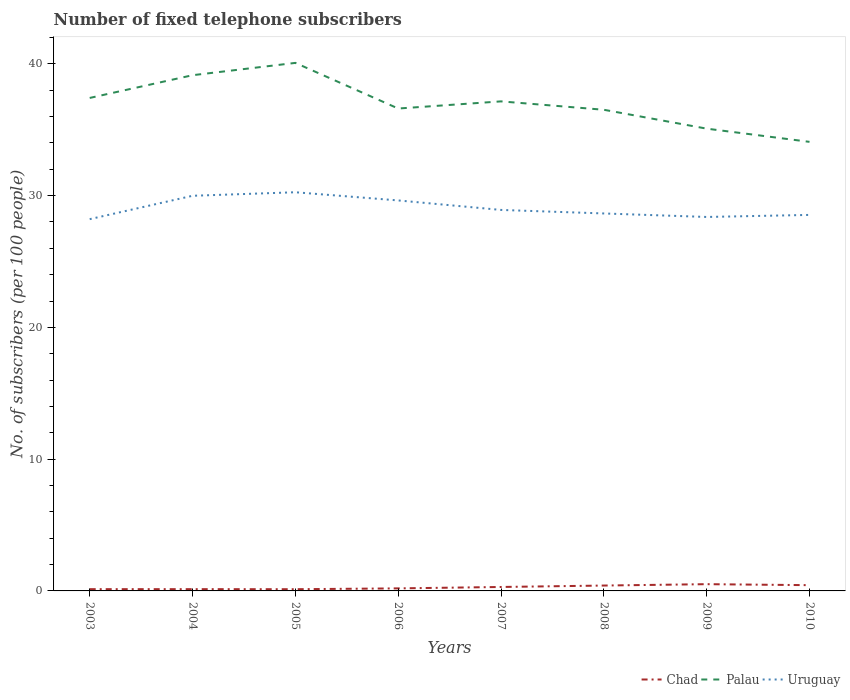Across all years, what is the maximum number of fixed telephone subscribers in Palau?
Make the answer very short. 34.08. In which year was the number of fixed telephone subscribers in Chad maximum?
Provide a short and direct response. 2005. What is the total number of fixed telephone subscribers in Uruguay in the graph?
Keep it short and to the point. 0.62. What is the difference between the highest and the second highest number of fixed telephone subscribers in Uruguay?
Offer a very short reply. 2.04. What is the difference between the highest and the lowest number of fixed telephone subscribers in Chad?
Offer a terse response. 4. Is the number of fixed telephone subscribers in Uruguay strictly greater than the number of fixed telephone subscribers in Chad over the years?
Give a very brief answer. No. How many years are there in the graph?
Provide a succinct answer. 8. What is the difference between two consecutive major ticks on the Y-axis?
Your answer should be very brief. 10. Where does the legend appear in the graph?
Ensure brevity in your answer.  Bottom right. How many legend labels are there?
Your response must be concise. 3. What is the title of the graph?
Offer a very short reply. Number of fixed telephone subscribers. Does "Europe(developing only)" appear as one of the legend labels in the graph?
Your response must be concise. No. What is the label or title of the Y-axis?
Your response must be concise. No. of subscribers (per 100 people). What is the No. of subscribers (per 100 people) in Chad in 2003?
Provide a succinct answer. 0.13. What is the No. of subscribers (per 100 people) in Palau in 2003?
Offer a terse response. 37.41. What is the No. of subscribers (per 100 people) of Uruguay in 2003?
Provide a succinct answer. 28.21. What is the No. of subscribers (per 100 people) of Chad in 2004?
Your answer should be compact. 0.13. What is the No. of subscribers (per 100 people) of Palau in 2004?
Keep it short and to the point. 39.14. What is the No. of subscribers (per 100 people) in Uruguay in 2004?
Offer a terse response. 29.99. What is the No. of subscribers (per 100 people) of Chad in 2005?
Your response must be concise. 0.13. What is the No. of subscribers (per 100 people) in Palau in 2005?
Offer a very short reply. 40.07. What is the No. of subscribers (per 100 people) of Uruguay in 2005?
Provide a short and direct response. 30.25. What is the No. of subscribers (per 100 people) in Chad in 2006?
Your answer should be very brief. 0.19. What is the No. of subscribers (per 100 people) of Palau in 2006?
Provide a succinct answer. 36.61. What is the No. of subscribers (per 100 people) of Uruguay in 2006?
Give a very brief answer. 29.63. What is the No. of subscribers (per 100 people) in Chad in 2007?
Provide a short and direct response. 0.3. What is the No. of subscribers (per 100 people) of Palau in 2007?
Provide a short and direct response. 37.15. What is the No. of subscribers (per 100 people) of Uruguay in 2007?
Your response must be concise. 28.91. What is the No. of subscribers (per 100 people) of Chad in 2008?
Provide a short and direct response. 0.41. What is the No. of subscribers (per 100 people) of Palau in 2008?
Provide a short and direct response. 36.51. What is the No. of subscribers (per 100 people) of Uruguay in 2008?
Your answer should be very brief. 28.64. What is the No. of subscribers (per 100 people) in Chad in 2009?
Give a very brief answer. 0.51. What is the No. of subscribers (per 100 people) in Palau in 2009?
Your answer should be compact. 35.08. What is the No. of subscribers (per 100 people) in Uruguay in 2009?
Your answer should be compact. 28.38. What is the No. of subscribers (per 100 people) of Chad in 2010?
Keep it short and to the point. 0.44. What is the No. of subscribers (per 100 people) in Palau in 2010?
Offer a terse response. 34.08. What is the No. of subscribers (per 100 people) of Uruguay in 2010?
Your response must be concise. 28.53. Across all years, what is the maximum No. of subscribers (per 100 people) of Chad?
Your answer should be very brief. 0.51. Across all years, what is the maximum No. of subscribers (per 100 people) in Palau?
Keep it short and to the point. 40.07. Across all years, what is the maximum No. of subscribers (per 100 people) of Uruguay?
Offer a very short reply. 30.25. Across all years, what is the minimum No. of subscribers (per 100 people) in Chad?
Your answer should be very brief. 0.13. Across all years, what is the minimum No. of subscribers (per 100 people) of Palau?
Provide a succinct answer. 34.08. Across all years, what is the minimum No. of subscribers (per 100 people) in Uruguay?
Your answer should be very brief. 28.21. What is the total No. of subscribers (per 100 people) of Chad in the graph?
Keep it short and to the point. 2.25. What is the total No. of subscribers (per 100 people) in Palau in the graph?
Your answer should be very brief. 296.05. What is the total No. of subscribers (per 100 people) in Uruguay in the graph?
Provide a succinct answer. 232.56. What is the difference between the No. of subscribers (per 100 people) in Chad in 2003 and that in 2004?
Your answer should be compact. -0. What is the difference between the No. of subscribers (per 100 people) of Palau in 2003 and that in 2004?
Provide a succinct answer. -1.73. What is the difference between the No. of subscribers (per 100 people) of Uruguay in 2003 and that in 2004?
Keep it short and to the point. -1.77. What is the difference between the No. of subscribers (per 100 people) in Chad in 2003 and that in 2005?
Provide a short and direct response. 0. What is the difference between the No. of subscribers (per 100 people) of Palau in 2003 and that in 2005?
Keep it short and to the point. -2.66. What is the difference between the No. of subscribers (per 100 people) in Uruguay in 2003 and that in 2005?
Give a very brief answer. -2.04. What is the difference between the No. of subscribers (per 100 people) in Chad in 2003 and that in 2006?
Provide a succinct answer. -0.06. What is the difference between the No. of subscribers (per 100 people) in Palau in 2003 and that in 2006?
Your response must be concise. 0.8. What is the difference between the No. of subscribers (per 100 people) of Uruguay in 2003 and that in 2006?
Ensure brevity in your answer.  -1.42. What is the difference between the No. of subscribers (per 100 people) of Chad in 2003 and that in 2007?
Ensure brevity in your answer.  -0.17. What is the difference between the No. of subscribers (per 100 people) of Palau in 2003 and that in 2007?
Give a very brief answer. 0.26. What is the difference between the No. of subscribers (per 100 people) in Chad in 2003 and that in 2008?
Ensure brevity in your answer.  -0.27. What is the difference between the No. of subscribers (per 100 people) of Palau in 2003 and that in 2008?
Ensure brevity in your answer.  0.9. What is the difference between the No. of subscribers (per 100 people) in Uruguay in 2003 and that in 2008?
Provide a succinct answer. -0.43. What is the difference between the No. of subscribers (per 100 people) of Chad in 2003 and that in 2009?
Offer a very short reply. -0.38. What is the difference between the No. of subscribers (per 100 people) of Palau in 2003 and that in 2009?
Provide a succinct answer. 2.33. What is the difference between the No. of subscribers (per 100 people) in Uruguay in 2003 and that in 2009?
Make the answer very short. -0.17. What is the difference between the No. of subscribers (per 100 people) of Chad in 2003 and that in 2010?
Your answer should be compact. -0.3. What is the difference between the No. of subscribers (per 100 people) in Palau in 2003 and that in 2010?
Your answer should be compact. 3.33. What is the difference between the No. of subscribers (per 100 people) in Uruguay in 2003 and that in 2010?
Your answer should be very brief. -0.32. What is the difference between the No. of subscribers (per 100 people) in Chad in 2004 and that in 2005?
Offer a terse response. 0. What is the difference between the No. of subscribers (per 100 people) in Palau in 2004 and that in 2005?
Make the answer very short. -0.93. What is the difference between the No. of subscribers (per 100 people) of Uruguay in 2004 and that in 2005?
Ensure brevity in your answer.  -0.27. What is the difference between the No. of subscribers (per 100 people) in Chad in 2004 and that in 2006?
Your response must be concise. -0.06. What is the difference between the No. of subscribers (per 100 people) of Palau in 2004 and that in 2006?
Keep it short and to the point. 2.53. What is the difference between the No. of subscribers (per 100 people) in Uruguay in 2004 and that in 2006?
Your answer should be compact. 0.35. What is the difference between the No. of subscribers (per 100 people) of Chad in 2004 and that in 2007?
Keep it short and to the point. -0.16. What is the difference between the No. of subscribers (per 100 people) in Palau in 2004 and that in 2007?
Your response must be concise. 1.99. What is the difference between the No. of subscribers (per 100 people) in Uruguay in 2004 and that in 2007?
Provide a succinct answer. 1.07. What is the difference between the No. of subscribers (per 100 people) in Chad in 2004 and that in 2008?
Provide a short and direct response. -0.27. What is the difference between the No. of subscribers (per 100 people) in Palau in 2004 and that in 2008?
Make the answer very short. 2.62. What is the difference between the No. of subscribers (per 100 people) of Uruguay in 2004 and that in 2008?
Your answer should be very brief. 1.34. What is the difference between the No. of subscribers (per 100 people) in Chad in 2004 and that in 2009?
Provide a short and direct response. -0.38. What is the difference between the No. of subscribers (per 100 people) in Palau in 2004 and that in 2009?
Provide a short and direct response. 4.05. What is the difference between the No. of subscribers (per 100 people) in Uruguay in 2004 and that in 2009?
Make the answer very short. 1.61. What is the difference between the No. of subscribers (per 100 people) of Chad in 2004 and that in 2010?
Offer a terse response. -0.3. What is the difference between the No. of subscribers (per 100 people) in Palau in 2004 and that in 2010?
Offer a very short reply. 5.06. What is the difference between the No. of subscribers (per 100 people) in Uruguay in 2004 and that in 2010?
Your answer should be compact. 1.45. What is the difference between the No. of subscribers (per 100 people) of Chad in 2005 and that in 2006?
Provide a short and direct response. -0.06. What is the difference between the No. of subscribers (per 100 people) in Palau in 2005 and that in 2006?
Provide a short and direct response. 3.46. What is the difference between the No. of subscribers (per 100 people) in Uruguay in 2005 and that in 2006?
Keep it short and to the point. 0.62. What is the difference between the No. of subscribers (per 100 people) in Chad in 2005 and that in 2007?
Keep it short and to the point. -0.17. What is the difference between the No. of subscribers (per 100 people) of Palau in 2005 and that in 2007?
Offer a very short reply. 2.92. What is the difference between the No. of subscribers (per 100 people) of Uruguay in 2005 and that in 2007?
Your answer should be very brief. 1.34. What is the difference between the No. of subscribers (per 100 people) of Chad in 2005 and that in 2008?
Offer a terse response. -0.28. What is the difference between the No. of subscribers (per 100 people) in Palau in 2005 and that in 2008?
Make the answer very short. 3.56. What is the difference between the No. of subscribers (per 100 people) of Uruguay in 2005 and that in 2008?
Offer a very short reply. 1.61. What is the difference between the No. of subscribers (per 100 people) in Chad in 2005 and that in 2009?
Your answer should be compact. -0.38. What is the difference between the No. of subscribers (per 100 people) in Palau in 2005 and that in 2009?
Offer a terse response. 4.99. What is the difference between the No. of subscribers (per 100 people) in Uruguay in 2005 and that in 2009?
Offer a terse response. 1.88. What is the difference between the No. of subscribers (per 100 people) in Chad in 2005 and that in 2010?
Your answer should be very brief. -0.31. What is the difference between the No. of subscribers (per 100 people) in Palau in 2005 and that in 2010?
Provide a short and direct response. 5.99. What is the difference between the No. of subscribers (per 100 people) of Uruguay in 2005 and that in 2010?
Give a very brief answer. 1.72. What is the difference between the No. of subscribers (per 100 people) of Chad in 2006 and that in 2007?
Ensure brevity in your answer.  -0.11. What is the difference between the No. of subscribers (per 100 people) of Palau in 2006 and that in 2007?
Provide a short and direct response. -0.54. What is the difference between the No. of subscribers (per 100 people) of Uruguay in 2006 and that in 2007?
Your response must be concise. 0.72. What is the difference between the No. of subscribers (per 100 people) in Chad in 2006 and that in 2008?
Your answer should be compact. -0.21. What is the difference between the No. of subscribers (per 100 people) of Palau in 2006 and that in 2008?
Offer a very short reply. 0.09. What is the difference between the No. of subscribers (per 100 people) in Uruguay in 2006 and that in 2008?
Your answer should be very brief. 0.99. What is the difference between the No. of subscribers (per 100 people) in Chad in 2006 and that in 2009?
Make the answer very short. -0.32. What is the difference between the No. of subscribers (per 100 people) of Palau in 2006 and that in 2009?
Make the answer very short. 1.53. What is the difference between the No. of subscribers (per 100 people) in Uruguay in 2006 and that in 2009?
Keep it short and to the point. 1.25. What is the difference between the No. of subscribers (per 100 people) of Chad in 2006 and that in 2010?
Your response must be concise. -0.24. What is the difference between the No. of subscribers (per 100 people) in Palau in 2006 and that in 2010?
Your response must be concise. 2.53. What is the difference between the No. of subscribers (per 100 people) of Uruguay in 2006 and that in 2010?
Your response must be concise. 1.1. What is the difference between the No. of subscribers (per 100 people) in Chad in 2007 and that in 2008?
Provide a short and direct response. -0.11. What is the difference between the No. of subscribers (per 100 people) in Palau in 2007 and that in 2008?
Keep it short and to the point. 0.64. What is the difference between the No. of subscribers (per 100 people) in Uruguay in 2007 and that in 2008?
Give a very brief answer. 0.27. What is the difference between the No. of subscribers (per 100 people) in Chad in 2007 and that in 2009?
Ensure brevity in your answer.  -0.21. What is the difference between the No. of subscribers (per 100 people) in Palau in 2007 and that in 2009?
Your response must be concise. 2.07. What is the difference between the No. of subscribers (per 100 people) of Uruguay in 2007 and that in 2009?
Your response must be concise. 0.53. What is the difference between the No. of subscribers (per 100 people) of Chad in 2007 and that in 2010?
Offer a very short reply. -0.14. What is the difference between the No. of subscribers (per 100 people) of Palau in 2007 and that in 2010?
Your answer should be compact. 3.07. What is the difference between the No. of subscribers (per 100 people) in Uruguay in 2007 and that in 2010?
Offer a very short reply. 0.38. What is the difference between the No. of subscribers (per 100 people) of Chad in 2008 and that in 2009?
Offer a terse response. -0.1. What is the difference between the No. of subscribers (per 100 people) in Palau in 2008 and that in 2009?
Ensure brevity in your answer.  1.43. What is the difference between the No. of subscribers (per 100 people) in Uruguay in 2008 and that in 2009?
Ensure brevity in your answer.  0.27. What is the difference between the No. of subscribers (per 100 people) of Chad in 2008 and that in 2010?
Your answer should be very brief. -0.03. What is the difference between the No. of subscribers (per 100 people) in Palau in 2008 and that in 2010?
Offer a terse response. 2.43. What is the difference between the No. of subscribers (per 100 people) in Uruguay in 2008 and that in 2010?
Ensure brevity in your answer.  0.11. What is the difference between the No. of subscribers (per 100 people) in Chad in 2009 and that in 2010?
Your answer should be very brief. 0.08. What is the difference between the No. of subscribers (per 100 people) in Palau in 2009 and that in 2010?
Provide a short and direct response. 1. What is the difference between the No. of subscribers (per 100 people) in Uruguay in 2009 and that in 2010?
Provide a short and direct response. -0.16. What is the difference between the No. of subscribers (per 100 people) in Chad in 2003 and the No. of subscribers (per 100 people) in Palau in 2004?
Keep it short and to the point. -39. What is the difference between the No. of subscribers (per 100 people) in Chad in 2003 and the No. of subscribers (per 100 people) in Uruguay in 2004?
Provide a short and direct response. -29.85. What is the difference between the No. of subscribers (per 100 people) in Palau in 2003 and the No. of subscribers (per 100 people) in Uruguay in 2004?
Your response must be concise. 7.42. What is the difference between the No. of subscribers (per 100 people) in Chad in 2003 and the No. of subscribers (per 100 people) in Palau in 2005?
Provide a succinct answer. -39.94. What is the difference between the No. of subscribers (per 100 people) in Chad in 2003 and the No. of subscribers (per 100 people) in Uruguay in 2005?
Your response must be concise. -30.12. What is the difference between the No. of subscribers (per 100 people) in Palau in 2003 and the No. of subscribers (per 100 people) in Uruguay in 2005?
Offer a terse response. 7.16. What is the difference between the No. of subscribers (per 100 people) of Chad in 2003 and the No. of subscribers (per 100 people) of Palau in 2006?
Your answer should be compact. -36.47. What is the difference between the No. of subscribers (per 100 people) of Chad in 2003 and the No. of subscribers (per 100 people) of Uruguay in 2006?
Offer a very short reply. -29.5. What is the difference between the No. of subscribers (per 100 people) of Palau in 2003 and the No. of subscribers (per 100 people) of Uruguay in 2006?
Make the answer very short. 7.78. What is the difference between the No. of subscribers (per 100 people) in Chad in 2003 and the No. of subscribers (per 100 people) in Palau in 2007?
Your answer should be compact. -37.02. What is the difference between the No. of subscribers (per 100 people) of Chad in 2003 and the No. of subscribers (per 100 people) of Uruguay in 2007?
Provide a succinct answer. -28.78. What is the difference between the No. of subscribers (per 100 people) in Palau in 2003 and the No. of subscribers (per 100 people) in Uruguay in 2007?
Keep it short and to the point. 8.5. What is the difference between the No. of subscribers (per 100 people) in Chad in 2003 and the No. of subscribers (per 100 people) in Palau in 2008?
Keep it short and to the point. -36.38. What is the difference between the No. of subscribers (per 100 people) in Chad in 2003 and the No. of subscribers (per 100 people) in Uruguay in 2008?
Provide a short and direct response. -28.51. What is the difference between the No. of subscribers (per 100 people) of Palau in 2003 and the No. of subscribers (per 100 people) of Uruguay in 2008?
Your answer should be compact. 8.77. What is the difference between the No. of subscribers (per 100 people) of Chad in 2003 and the No. of subscribers (per 100 people) of Palau in 2009?
Your answer should be compact. -34.95. What is the difference between the No. of subscribers (per 100 people) of Chad in 2003 and the No. of subscribers (per 100 people) of Uruguay in 2009?
Your answer should be compact. -28.25. What is the difference between the No. of subscribers (per 100 people) of Palau in 2003 and the No. of subscribers (per 100 people) of Uruguay in 2009?
Give a very brief answer. 9.03. What is the difference between the No. of subscribers (per 100 people) of Chad in 2003 and the No. of subscribers (per 100 people) of Palau in 2010?
Give a very brief answer. -33.95. What is the difference between the No. of subscribers (per 100 people) of Chad in 2003 and the No. of subscribers (per 100 people) of Uruguay in 2010?
Make the answer very short. -28.4. What is the difference between the No. of subscribers (per 100 people) of Palau in 2003 and the No. of subscribers (per 100 people) of Uruguay in 2010?
Your answer should be compact. 8.88. What is the difference between the No. of subscribers (per 100 people) of Chad in 2004 and the No. of subscribers (per 100 people) of Palau in 2005?
Keep it short and to the point. -39.94. What is the difference between the No. of subscribers (per 100 people) of Chad in 2004 and the No. of subscribers (per 100 people) of Uruguay in 2005?
Your response must be concise. -30.12. What is the difference between the No. of subscribers (per 100 people) of Palau in 2004 and the No. of subscribers (per 100 people) of Uruguay in 2005?
Ensure brevity in your answer.  8.88. What is the difference between the No. of subscribers (per 100 people) in Chad in 2004 and the No. of subscribers (per 100 people) in Palau in 2006?
Provide a succinct answer. -36.47. What is the difference between the No. of subscribers (per 100 people) in Chad in 2004 and the No. of subscribers (per 100 people) in Uruguay in 2006?
Keep it short and to the point. -29.5. What is the difference between the No. of subscribers (per 100 people) in Palau in 2004 and the No. of subscribers (per 100 people) in Uruguay in 2006?
Ensure brevity in your answer.  9.5. What is the difference between the No. of subscribers (per 100 people) in Chad in 2004 and the No. of subscribers (per 100 people) in Palau in 2007?
Your answer should be very brief. -37.02. What is the difference between the No. of subscribers (per 100 people) in Chad in 2004 and the No. of subscribers (per 100 people) in Uruguay in 2007?
Your response must be concise. -28.78. What is the difference between the No. of subscribers (per 100 people) of Palau in 2004 and the No. of subscribers (per 100 people) of Uruguay in 2007?
Your answer should be very brief. 10.22. What is the difference between the No. of subscribers (per 100 people) in Chad in 2004 and the No. of subscribers (per 100 people) in Palau in 2008?
Make the answer very short. -36.38. What is the difference between the No. of subscribers (per 100 people) in Chad in 2004 and the No. of subscribers (per 100 people) in Uruguay in 2008?
Offer a terse response. -28.51. What is the difference between the No. of subscribers (per 100 people) of Palau in 2004 and the No. of subscribers (per 100 people) of Uruguay in 2008?
Provide a succinct answer. 10.49. What is the difference between the No. of subscribers (per 100 people) of Chad in 2004 and the No. of subscribers (per 100 people) of Palau in 2009?
Offer a terse response. -34.95. What is the difference between the No. of subscribers (per 100 people) of Chad in 2004 and the No. of subscribers (per 100 people) of Uruguay in 2009?
Your answer should be very brief. -28.24. What is the difference between the No. of subscribers (per 100 people) of Palau in 2004 and the No. of subscribers (per 100 people) of Uruguay in 2009?
Your answer should be very brief. 10.76. What is the difference between the No. of subscribers (per 100 people) in Chad in 2004 and the No. of subscribers (per 100 people) in Palau in 2010?
Your answer should be very brief. -33.94. What is the difference between the No. of subscribers (per 100 people) of Chad in 2004 and the No. of subscribers (per 100 people) of Uruguay in 2010?
Ensure brevity in your answer.  -28.4. What is the difference between the No. of subscribers (per 100 people) of Palau in 2004 and the No. of subscribers (per 100 people) of Uruguay in 2010?
Your response must be concise. 10.6. What is the difference between the No. of subscribers (per 100 people) of Chad in 2005 and the No. of subscribers (per 100 people) of Palau in 2006?
Keep it short and to the point. -36.48. What is the difference between the No. of subscribers (per 100 people) of Chad in 2005 and the No. of subscribers (per 100 people) of Uruguay in 2006?
Your answer should be compact. -29.5. What is the difference between the No. of subscribers (per 100 people) in Palau in 2005 and the No. of subscribers (per 100 people) in Uruguay in 2006?
Offer a very short reply. 10.44. What is the difference between the No. of subscribers (per 100 people) in Chad in 2005 and the No. of subscribers (per 100 people) in Palau in 2007?
Provide a short and direct response. -37.02. What is the difference between the No. of subscribers (per 100 people) of Chad in 2005 and the No. of subscribers (per 100 people) of Uruguay in 2007?
Ensure brevity in your answer.  -28.78. What is the difference between the No. of subscribers (per 100 people) of Palau in 2005 and the No. of subscribers (per 100 people) of Uruguay in 2007?
Make the answer very short. 11.16. What is the difference between the No. of subscribers (per 100 people) in Chad in 2005 and the No. of subscribers (per 100 people) in Palau in 2008?
Give a very brief answer. -36.38. What is the difference between the No. of subscribers (per 100 people) in Chad in 2005 and the No. of subscribers (per 100 people) in Uruguay in 2008?
Ensure brevity in your answer.  -28.52. What is the difference between the No. of subscribers (per 100 people) of Palau in 2005 and the No. of subscribers (per 100 people) of Uruguay in 2008?
Offer a very short reply. 11.43. What is the difference between the No. of subscribers (per 100 people) of Chad in 2005 and the No. of subscribers (per 100 people) of Palau in 2009?
Give a very brief answer. -34.95. What is the difference between the No. of subscribers (per 100 people) in Chad in 2005 and the No. of subscribers (per 100 people) in Uruguay in 2009?
Ensure brevity in your answer.  -28.25. What is the difference between the No. of subscribers (per 100 people) in Palau in 2005 and the No. of subscribers (per 100 people) in Uruguay in 2009?
Offer a very short reply. 11.69. What is the difference between the No. of subscribers (per 100 people) in Chad in 2005 and the No. of subscribers (per 100 people) in Palau in 2010?
Your response must be concise. -33.95. What is the difference between the No. of subscribers (per 100 people) in Chad in 2005 and the No. of subscribers (per 100 people) in Uruguay in 2010?
Your answer should be compact. -28.4. What is the difference between the No. of subscribers (per 100 people) in Palau in 2005 and the No. of subscribers (per 100 people) in Uruguay in 2010?
Keep it short and to the point. 11.54. What is the difference between the No. of subscribers (per 100 people) in Chad in 2006 and the No. of subscribers (per 100 people) in Palau in 2007?
Make the answer very short. -36.96. What is the difference between the No. of subscribers (per 100 people) in Chad in 2006 and the No. of subscribers (per 100 people) in Uruguay in 2007?
Offer a very short reply. -28.72. What is the difference between the No. of subscribers (per 100 people) in Palau in 2006 and the No. of subscribers (per 100 people) in Uruguay in 2007?
Ensure brevity in your answer.  7.7. What is the difference between the No. of subscribers (per 100 people) of Chad in 2006 and the No. of subscribers (per 100 people) of Palau in 2008?
Ensure brevity in your answer.  -36.32. What is the difference between the No. of subscribers (per 100 people) in Chad in 2006 and the No. of subscribers (per 100 people) in Uruguay in 2008?
Your response must be concise. -28.45. What is the difference between the No. of subscribers (per 100 people) in Palau in 2006 and the No. of subscribers (per 100 people) in Uruguay in 2008?
Offer a very short reply. 7.96. What is the difference between the No. of subscribers (per 100 people) in Chad in 2006 and the No. of subscribers (per 100 people) in Palau in 2009?
Give a very brief answer. -34.89. What is the difference between the No. of subscribers (per 100 people) in Chad in 2006 and the No. of subscribers (per 100 people) in Uruguay in 2009?
Make the answer very short. -28.19. What is the difference between the No. of subscribers (per 100 people) of Palau in 2006 and the No. of subscribers (per 100 people) of Uruguay in 2009?
Provide a short and direct response. 8.23. What is the difference between the No. of subscribers (per 100 people) of Chad in 2006 and the No. of subscribers (per 100 people) of Palau in 2010?
Your response must be concise. -33.89. What is the difference between the No. of subscribers (per 100 people) in Chad in 2006 and the No. of subscribers (per 100 people) in Uruguay in 2010?
Your answer should be very brief. -28.34. What is the difference between the No. of subscribers (per 100 people) in Palau in 2006 and the No. of subscribers (per 100 people) in Uruguay in 2010?
Provide a succinct answer. 8.07. What is the difference between the No. of subscribers (per 100 people) of Chad in 2007 and the No. of subscribers (per 100 people) of Palau in 2008?
Keep it short and to the point. -36.21. What is the difference between the No. of subscribers (per 100 people) of Chad in 2007 and the No. of subscribers (per 100 people) of Uruguay in 2008?
Your answer should be compact. -28.35. What is the difference between the No. of subscribers (per 100 people) in Palau in 2007 and the No. of subscribers (per 100 people) in Uruguay in 2008?
Make the answer very short. 8.51. What is the difference between the No. of subscribers (per 100 people) of Chad in 2007 and the No. of subscribers (per 100 people) of Palau in 2009?
Give a very brief answer. -34.78. What is the difference between the No. of subscribers (per 100 people) of Chad in 2007 and the No. of subscribers (per 100 people) of Uruguay in 2009?
Keep it short and to the point. -28.08. What is the difference between the No. of subscribers (per 100 people) in Palau in 2007 and the No. of subscribers (per 100 people) in Uruguay in 2009?
Provide a short and direct response. 8.77. What is the difference between the No. of subscribers (per 100 people) in Chad in 2007 and the No. of subscribers (per 100 people) in Palau in 2010?
Make the answer very short. -33.78. What is the difference between the No. of subscribers (per 100 people) of Chad in 2007 and the No. of subscribers (per 100 people) of Uruguay in 2010?
Offer a very short reply. -28.24. What is the difference between the No. of subscribers (per 100 people) in Palau in 2007 and the No. of subscribers (per 100 people) in Uruguay in 2010?
Your response must be concise. 8.62. What is the difference between the No. of subscribers (per 100 people) of Chad in 2008 and the No. of subscribers (per 100 people) of Palau in 2009?
Your response must be concise. -34.67. What is the difference between the No. of subscribers (per 100 people) in Chad in 2008 and the No. of subscribers (per 100 people) in Uruguay in 2009?
Give a very brief answer. -27.97. What is the difference between the No. of subscribers (per 100 people) in Palau in 2008 and the No. of subscribers (per 100 people) in Uruguay in 2009?
Offer a very short reply. 8.13. What is the difference between the No. of subscribers (per 100 people) in Chad in 2008 and the No. of subscribers (per 100 people) in Palau in 2010?
Make the answer very short. -33.67. What is the difference between the No. of subscribers (per 100 people) in Chad in 2008 and the No. of subscribers (per 100 people) in Uruguay in 2010?
Your answer should be compact. -28.13. What is the difference between the No. of subscribers (per 100 people) of Palau in 2008 and the No. of subscribers (per 100 people) of Uruguay in 2010?
Provide a succinct answer. 7.98. What is the difference between the No. of subscribers (per 100 people) of Chad in 2009 and the No. of subscribers (per 100 people) of Palau in 2010?
Your response must be concise. -33.57. What is the difference between the No. of subscribers (per 100 people) in Chad in 2009 and the No. of subscribers (per 100 people) in Uruguay in 2010?
Give a very brief answer. -28.02. What is the difference between the No. of subscribers (per 100 people) in Palau in 2009 and the No. of subscribers (per 100 people) in Uruguay in 2010?
Your answer should be compact. 6.55. What is the average No. of subscribers (per 100 people) of Chad per year?
Offer a very short reply. 0.28. What is the average No. of subscribers (per 100 people) in Palau per year?
Offer a terse response. 37.01. What is the average No. of subscribers (per 100 people) of Uruguay per year?
Offer a terse response. 29.07. In the year 2003, what is the difference between the No. of subscribers (per 100 people) in Chad and No. of subscribers (per 100 people) in Palau?
Offer a terse response. -37.28. In the year 2003, what is the difference between the No. of subscribers (per 100 people) in Chad and No. of subscribers (per 100 people) in Uruguay?
Keep it short and to the point. -28.08. In the year 2003, what is the difference between the No. of subscribers (per 100 people) of Palau and No. of subscribers (per 100 people) of Uruguay?
Your response must be concise. 9.2. In the year 2004, what is the difference between the No. of subscribers (per 100 people) in Chad and No. of subscribers (per 100 people) in Palau?
Provide a short and direct response. -39. In the year 2004, what is the difference between the No. of subscribers (per 100 people) in Chad and No. of subscribers (per 100 people) in Uruguay?
Offer a terse response. -29.85. In the year 2004, what is the difference between the No. of subscribers (per 100 people) in Palau and No. of subscribers (per 100 people) in Uruguay?
Your answer should be compact. 9.15. In the year 2005, what is the difference between the No. of subscribers (per 100 people) of Chad and No. of subscribers (per 100 people) of Palau?
Your answer should be compact. -39.94. In the year 2005, what is the difference between the No. of subscribers (per 100 people) of Chad and No. of subscribers (per 100 people) of Uruguay?
Keep it short and to the point. -30.12. In the year 2005, what is the difference between the No. of subscribers (per 100 people) of Palau and No. of subscribers (per 100 people) of Uruguay?
Your answer should be compact. 9.82. In the year 2006, what is the difference between the No. of subscribers (per 100 people) in Chad and No. of subscribers (per 100 people) in Palau?
Keep it short and to the point. -36.41. In the year 2006, what is the difference between the No. of subscribers (per 100 people) in Chad and No. of subscribers (per 100 people) in Uruguay?
Provide a short and direct response. -29.44. In the year 2006, what is the difference between the No. of subscribers (per 100 people) of Palau and No. of subscribers (per 100 people) of Uruguay?
Provide a succinct answer. 6.97. In the year 2007, what is the difference between the No. of subscribers (per 100 people) of Chad and No. of subscribers (per 100 people) of Palau?
Your answer should be very brief. -36.85. In the year 2007, what is the difference between the No. of subscribers (per 100 people) in Chad and No. of subscribers (per 100 people) in Uruguay?
Provide a short and direct response. -28.61. In the year 2007, what is the difference between the No. of subscribers (per 100 people) in Palau and No. of subscribers (per 100 people) in Uruguay?
Your answer should be very brief. 8.24. In the year 2008, what is the difference between the No. of subscribers (per 100 people) of Chad and No. of subscribers (per 100 people) of Palau?
Offer a terse response. -36.11. In the year 2008, what is the difference between the No. of subscribers (per 100 people) of Chad and No. of subscribers (per 100 people) of Uruguay?
Your response must be concise. -28.24. In the year 2008, what is the difference between the No. of subscribers (per 100 people) of Palau and No. of subscribers (per 100 people) of Uruguay?
Provide a short and direct response. 7.87. In the year 2009, what is the difference between the No. of subscribers (per 100 people) in Chad and No. of subscribers (per 100 people) in Palau?
Ensure brevity in your answer.  -34.57. In the year 2009, what is the difference between the No. of subscribers (per 100 people) of Chad and No. of subscribers (per 100 people) of Uruguay?
Your answer should be very brief. -27.87. In the year 2009, what is the difference between the No. of subscribers (per 100 people) of Palau and No. of subscribers (per 100 people) of Uruguay?
Your answer should be very brief. 6.7. In the year 2010, what is the difference between the No. of subscribers (per 100 people) of Chad and No. of subscribers (per 100 people) of Palau?
Your response must be concise. -33.64. In the year 2010, what is the difference between the No. of subscribers (per 100 people) of Chad and No. of subscribers (per 100 people) of Uruguay?
Your response must be concise. -28.1. In the year 2010, what is the difference between the No. of subscribers (per 100 people) in Palau and No. of subscribers (per 100 people) in Uruguay?
Provide a succinct answer. 5.54. What is the ratio of the No. of subscribers (per 100 people) in Palau in 2003 to that in 2004?
Provide a succinct answer. 0.96. What is the ratio of the No. of subscribers (per 100 people) of Uruguay in 2003 to that in 2004?
Offer a terse response. 0.94. What is the ratio of the No. of subscribers (per 100 people) in Palau in 2003 to that in 2005?
Your response must be concise. 0.93. What is the ratio of the No. of subscribers (per 100 people) of Uruguay in 2003 to that in 2005?
Your answer should be very brief. 0.93. What is the ratio of the No. of subscribers (per 100 people) of Chad in 2003 to that in 2006?
Make the answer very short. 0.69. What is the ratio of the No. of subscribers (per 100 people) in Palau in 2003 to that in 2006?
Your response must be concise. 1.02. What is the ratio of the No. of subscribers (per 100 people) in Uruguay in 2003 to that in 2006?
Your answer should be very brief. 0.95. What is the ratio of the No. of subscribers (per 100 people) of Chad in 2003 to that in 2007?
Your answer should be compact. 0.45. What is the ratio of the No. of subscribers (per 100 people) of Uruguay in 2003 to that in 2007?
Give a very brief answer. 0.98. What is the ratio of the No. of subscribers (per 100 people) in Chad in 2003 to that in 2008?
Offer a very short reply. 0.33. What is the ratio of the No. of subscribers (per 100 people) in Palau in 2003 to that in 2008?
Provide a short and direct response. 1.02. What is the ratio of the No. of subscribers (per 100 people) in Uruguay in 2003 to that in 2008?
Provide a short and direct response. 0.98. What is the ratio of the No. of subscribers (per 100 people) of Chad in 2003 to that in 2009?
Your answer should be compact. 0.26. What is the ratio of the No. of subscribers (per 100 people) of Palau in 2003 to that in 2009?
Offer a terse response. 1.07. What is the ratio of the No. of subscribers (per 100 people) in Chad in 2003 to that in 2010?
Provide a succinct answer. 0.31. What is the ratio of the No. of subscribers (per 100 people) of Palau in 2003 to that in 2010?
Give a very brief answer. 1.1. What is the ratio of the No. of subscribers (per 100 people) in Uruguay in 2003 to that in 2010?
Your answer should be very brief. 0.99. What is the ratio of the No. of subscribers (per 100 people) of Chad in 2004 to that in 2005?
Your answer should be compact. 1.04. What is the ratio of the No. of subscribers (per 100 people) in Palau in 2004 to that in 2005?
Ensure brevity in your answer.  0.98. What is the ratio of the No. of subscribers (per 100 people) of Uruguay in 2004 to that in 2005?
Make the answer very short. 0.99. What is the ratio of the No. of subscribers (per 100 people) in Chad in 2004 to that in 2006?
Your answer should be very brief. 0.7. What is the ratio of the No. of subscribers (per 100 people) in Palau in 2004 to that in 2006?
Offer a very short reply. 1.07. What is the ratio of the No. of subscribers (per 100 people) of Uruguay in 2004 to that in 2006?
Keep it short and to the point. 1.01. What is the ratio of the No. of subscribers (per 100 people) in Chad in 2004 to that in 2007?
Your response must be concise. 0.45. What is the ratio of the No. of subscribers (per 100 people) in Palau in 2004 to that in 2007?
Offer a terse response. 1.05. What is the ratio of the No. of subscribers (per 100 people) of Uruguay in 2004 to that in 2007?
Keep it short and to the point. 1.04. What is the ratio of the No. of subscribers (per 100 people) of Chad in 2004 to that in 2008?
Offer a terse response. 0.33. What is the ratio of the No. of subscribers (per 100 people) in Palau in 2004 to that in 2008?
Provide a succinct answer. 1.07. What is the ratio of the No. of subscribers (per 100 people) in Uruguay in 2004 to that in 2008?
Provide a short and direct response. 1.05. What is the ratio of the No. of subscribers (per 100 people) of Chad in 2004 to that in 2009?
Your answer should be very brief. 0.26. What is the ratio of the No. of subscribers (per 100 people) of Palau in 2004 to that in 2009?
Offer a very short reply. 1.12. What is the ratio of the No. of subscribers (per 100 people) in Uruguay in 2004 to that in 2009?
Give a very brief answer. 1.06. What is the ratio of the No. of subscribers (per 100 people) of Chad in 2004 to that in 2010?
Provide a succinct answer. 0.31. What is the ratio of the No. of subscribers (per 100 people) of Palau in 2004 to that in 2010?
Provide a succinct answer. 1.15. What is the ratio of the No. of subscribers (per 100 people) in Uruguay in 2004 to that in 2010?
Your answer should be compact. 1.05. What is the ratio of the No. of subscribers (per 100 people) of Chad in 2005 to that in 2006?
Make the answer very short. 0.67. What is the ratio of the No. of subscribers (per 100 people) in Palau in 2005 to that in 2006?
Offer a very short reply. 1.09. What is the ratio of the No. of subscribers (per 100 people) in Uruguay in 2005 to that in 2006?
Provide a succinct answer. 1.02. What is the ratio of the No. of subscribers (per 100 people) of Chad in 2005 to that in 2007?
Your answer should be very brief. 0.43. What is the ratio of the No. of subscribers (per 100 people) of Palau in 2005 to that in 2007?
Keep it short and to the point. 1.08. What is the ratio of the No. of subscribers (per 100 people) of Uruguay in 2005 to that in 2007?
Ensure brevity in your answer.  1.05. What is the ratio of the No. of subscribers (per 100 people) in Chad in 2005 to that in 2008?
Provide a short and direct response. 0.32. What is the ratio of the No. of subscribers (per 100 people) of Palau in 2005 to that in 2008?
Provide a succinct answer. 1.1. What is the ratio of the No. of subscribers (per 100 people) of Uruguay in 2005 to that in 2008?
Offer a very short reply. 1.06. What is the ratio of the No. of subscribers (per 100 people) of Chad in 2005 to that in 2009?
Keep it short and to the point. 0.25. What is the ratio of the No. of subscribers (per 100 people) of Palau in 2005 to that in 2009?
Offer a very short reply. 1.14. What is the ratio of the No. of subscribers (per 100 people) of Uruguay in 2005 to that in 2009?
Offer a terse response. 1.07. What is the ratio of the No. of subscribers (per 100 people) in Chad in 2005 to that in 2010?
Make the answer very short. 0.3. What is the ratio of the No. of subscribers (per 100 people) in Palau in 2005 to that in 2010?
Your response must be concise. 1.18. What is the ratio of the No. of subscribers (per 100 people) in Uruguay in 2005 to that in 2010?
Give a very brief answer. 1.06. What is the ratio of the No. of subscribers (per 100 people) in Chad in 2006 to that in 2007?
Give a very brief answer. 0.65. What is the ratio of the No. of subscribers (per 100 people) of Palau in 2006 to that in 2007?
Offer a terse response. 0.99. What is the ratio of the No. of subscribers (per 100 people) of Uruguay in 2006 to that in 2007?
Keep it short and to the point. 1.02. What is the ratio of the No. of subscribers (per 100 people) of Chad in 2006 to that in 2008?
Ensure brevity in your answer.  0.47. What is the ratio of the No. of subscribers (per 100 people) in Uruguay in 2006 to that in 2008?
Offer a terse response. 1.03. What is the ratio of the No. of subscribers (per 100 people) in Chad in 2006 to that in 2009?
Offer a very short reply. 0.38. What is the ratio of the No. of subscribers (per 100 people) in Palau in 2006 to that in 2009?
Your answer should be compact. 1.04. What is the ratio of the No. of subscribers (per 100 people) of Uruguay in 2006 to that in 2009?
Your answer should be very brief. 1.04. What is the ratio of the No. of subscribers (per 100 people) of Chad in 2006 to that in 2010?
Offer a terse response. 0.44. What is the ratio of the No. of subscribers (per 100 people) in Palau in 2006 to that in 2010?
Offer a terse response. 1.07. What is the ratio of the No. of subscribers (per 100 people) in Chad in 2007 to that in 2008?
Your response must be concise. 0.73. What is the ratio of the No. of subscribers (per 100 people) of Palau in 2007 to that in 2008?
Make the answer very short. 1.02. What is the ratio of the No. of subscribers (per 100 people) of Uruguay in 2007 to that in 2008?
Provide a succinct answer. 1.01. What is the ratio of the No. of subscribers (per 100 people) of Chad in 2007 to that in 2009?
Your response must be concise. 0.58. What is the ratio of the No. of subscribers (per 100 people) in Palau in 2007 to that in 2009?
Give a very brief answer. 1.06. What is the ratio of the No. of subscribers (per 100 people) in Uruguay in 2007 to that in 2009?
Give a very brief answer. 1.02. What is the ratio of the No. of subscribers (per 100 people) of Chad in 2007 to that in 2010?
Offer a terse response. 0.68. What is the ratio of the No. of subscribers (per 100 people) of Palau in 2007 to that in 2010?
Provide a succinct answer. 1.09. What is the ratio of the No. of subscribers (per 100 people) of Uruguay in 2007 to that in 2010?
Provide a short and direct response. 1.01. What is the ratio of the No. of subscribers (per 100 people) of Chad in 2008 to that in 2009?
Keep it short and to the point. 0.8. What is the ratio of the No. of subscribers (per 100 people) of Palau in 2008 to that in 2009?
Keep it short and to the point. 1.04. What is the ratio of the No. of subscribers (per 100 people) in Uruguay in 2008 to that in 2009?
Offer a terse response. 1.01. What is the ratio of the No. of subscribers (per 100 people) of Chad in 2008 to that in 2010?
Provide a short and direct response. 0.93. What is the ratio of the No. of subscribers (per 100 people) of Palau in 2008 to that in 2010?
Provide a succinct answer. 1.07. What is the ratio of the No. of subscribers (per 100 people) in Uruguay in 2008 to that in 2010?
Ensure brevity in your answer.  1. What is the ratio of the No. of subscribers (per 100 people) of Chad in 2009 to that in 2010?
Provide a succinct answer. 1.17. What is the ratio of the No. of subscribers (per 100 people) in Palau in 2009 to that in 2010?
Your response must be concise. 1.03. What is the ratio of the No. of subscribers (per 100 people) in Uruguay in 2009 to that in 2010?
Offer a very short reply. 0.99. What is the difference between the highest and the second highest No. of subscribers (per 100 people) in Chad?
Provide a succinct answer. 0.08. What is the difference between the highest and the second highest No. of subscribers (per 100 people) of Palau?
Make the answer very short. 0.93. What is the difference between the highest and the second highest No. of subscribers (per 100 people) of Uruguay?
Offer a very short reply. 0.27. What is the difference between the highest and the lowest No. of subscribers (per 100 people) in Chad?
Ensure brevity in your answer.  0.38. What is the difference between the highest and the lowest No. of subscribers (per 100 people) in Palau?
Offer a terse response. 5.99. What is the difference between the highest and the lowest No. of subscribers (per 100 people) of Uruguay?
Provide a succinct answer. 2.04. 